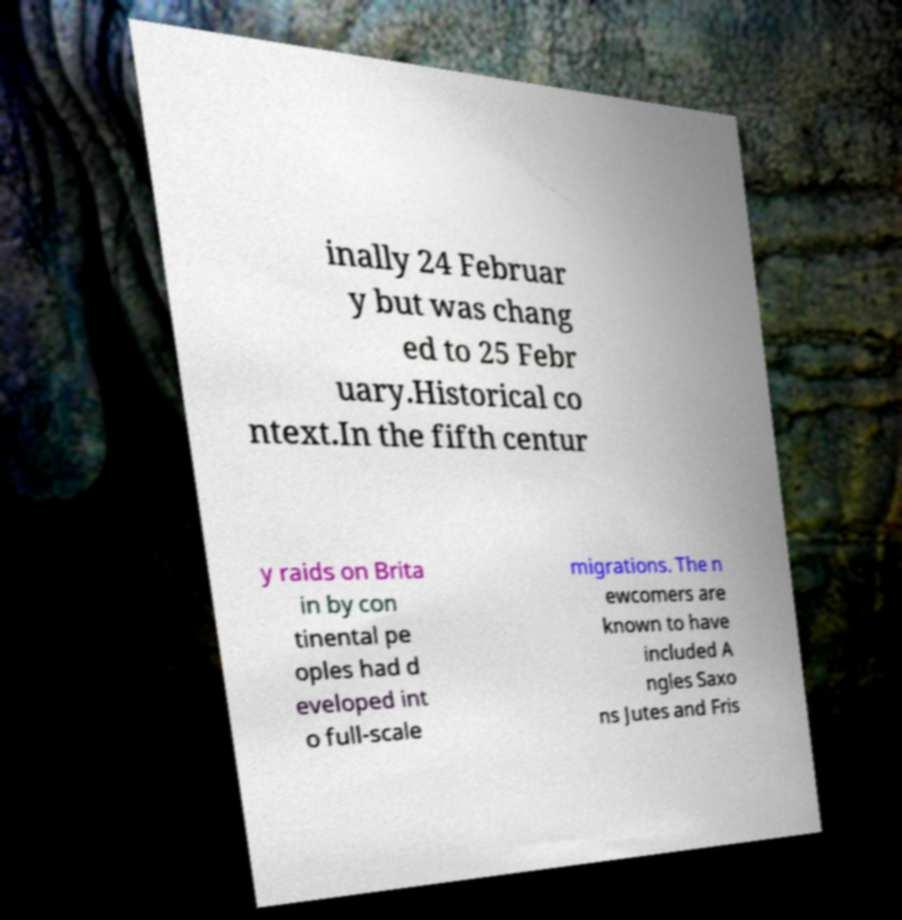For documentation purposes, I need the text within this image transcribed. Could you provide that? inally 24 Februar y but was chang ed to 25 Febr uary.Historical co ntext.In the fifth centur y raids on Brita in by con tinental pe oples had d eveloped int o full-scale migrations. The n ewcomers are known to have included A ngles Saxo ns Jutes and Fris 